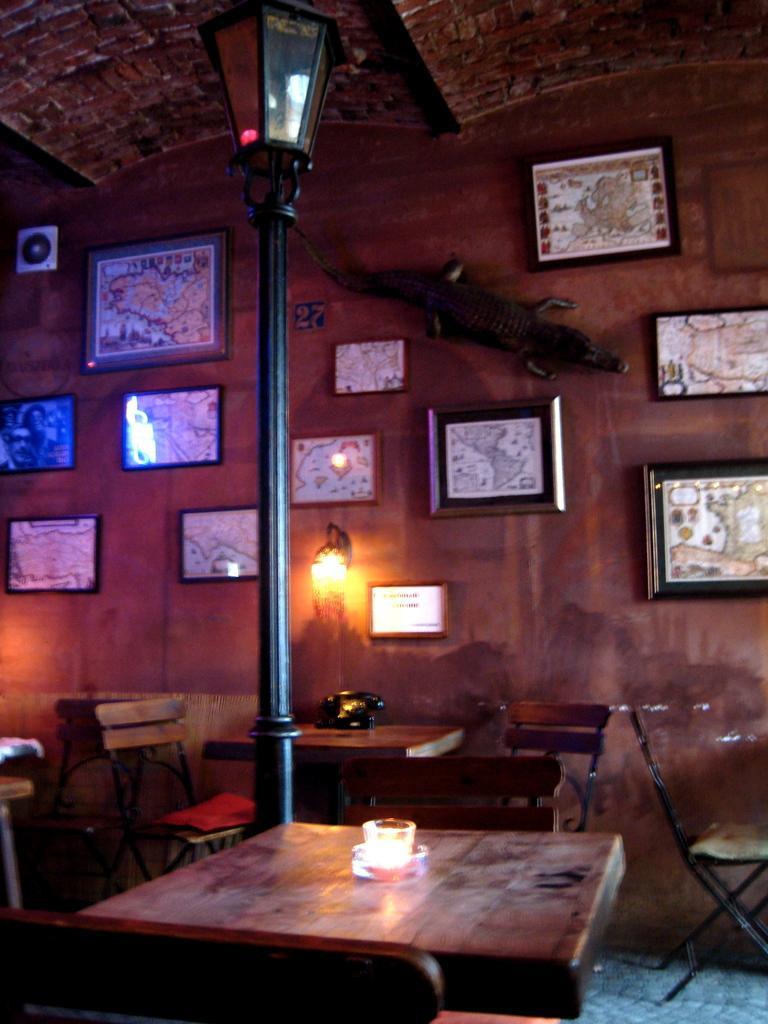Could you give a brief overview of what you see in this image? There is a lamp and a pole in this room beside the table on which a cup was placed. There are some chairs and a table here. In the background there are some photo frames attached to the wall. 